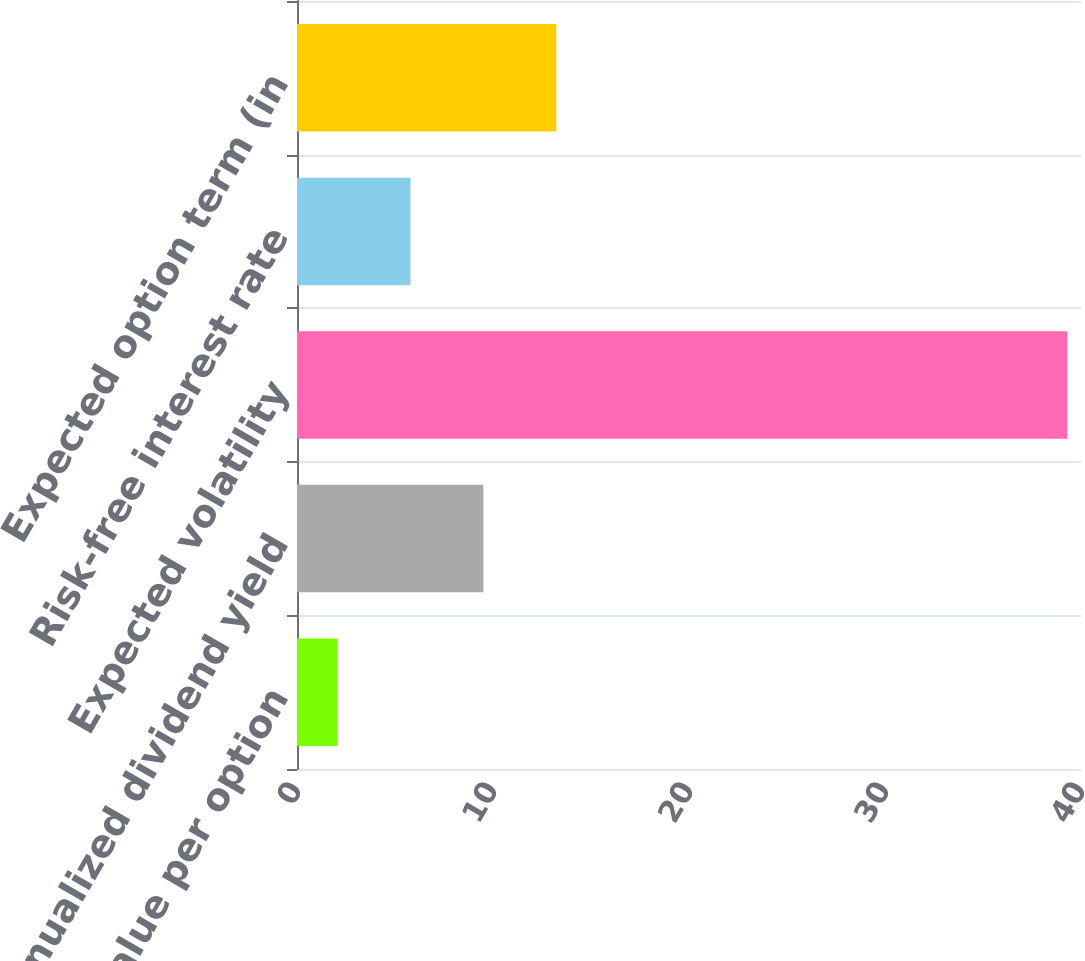<chart> <loc_0><loc_0><loc_500><loc_500><bar_chart><fcel>Fair value per option<fcel>Annualized dividend yield<fcel>Expected volatility<fcel>Risk-free interest rate<fcel>Expected option term (in<nl><fcel>2.07<fcel>9.51<fcel>39.3<fcel>5.79<fcel>13.23<nl></chart> 